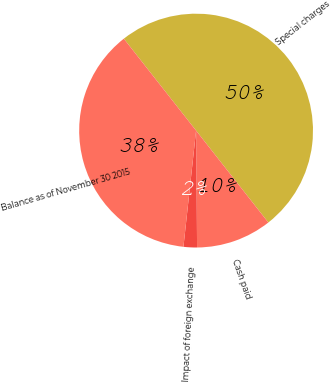Convert chart. <chart><loc_0><loc_0><loc_500><loc_500><pie_chart><fcel>Special charges<fcel>Cash paid<fcel>Impact of foreign exchange<fcel>Balance as of November 30 2015<nl><fcel>50.0%<fcel>10.47%<fcel>1.86%<fcel>37.67%<nl></chart> 